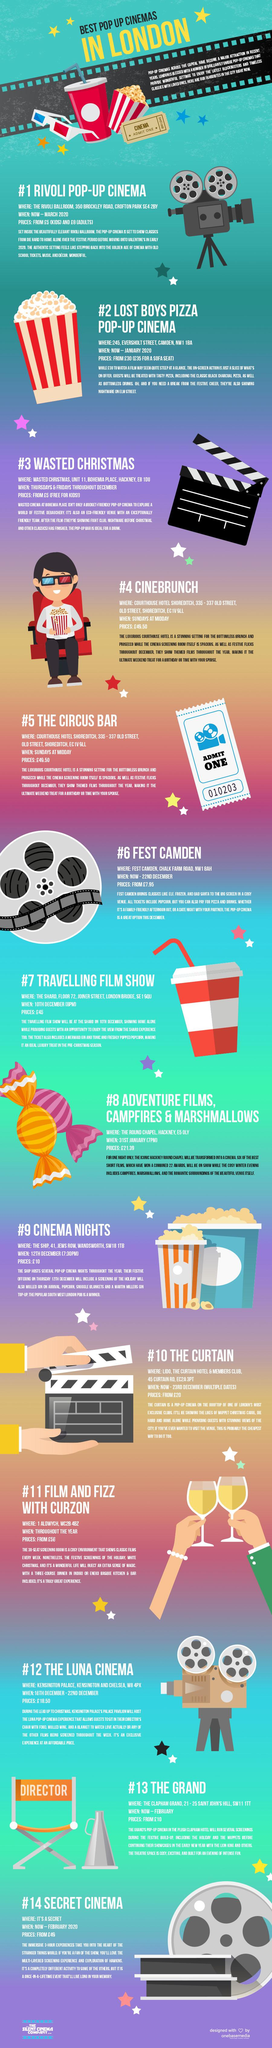Draw attention to some important aspects in this diagram. The pop-up with a rate between Wasted Christmas and Rivoli, Fest Camden is the one you are referring to. The chair beside #13 has writing on it that reads "DIRECTOR. Rivoli Pop-up Cinema offers a unique and affordable movie-going experience for children, with tickets priced at only 5. The number mentioned on the cinema ticket next to the popcorn packet is 000123456. I am informed that the pop-up event called 'Wasted Christmas' is offering free entry for children, as stated in the text. 